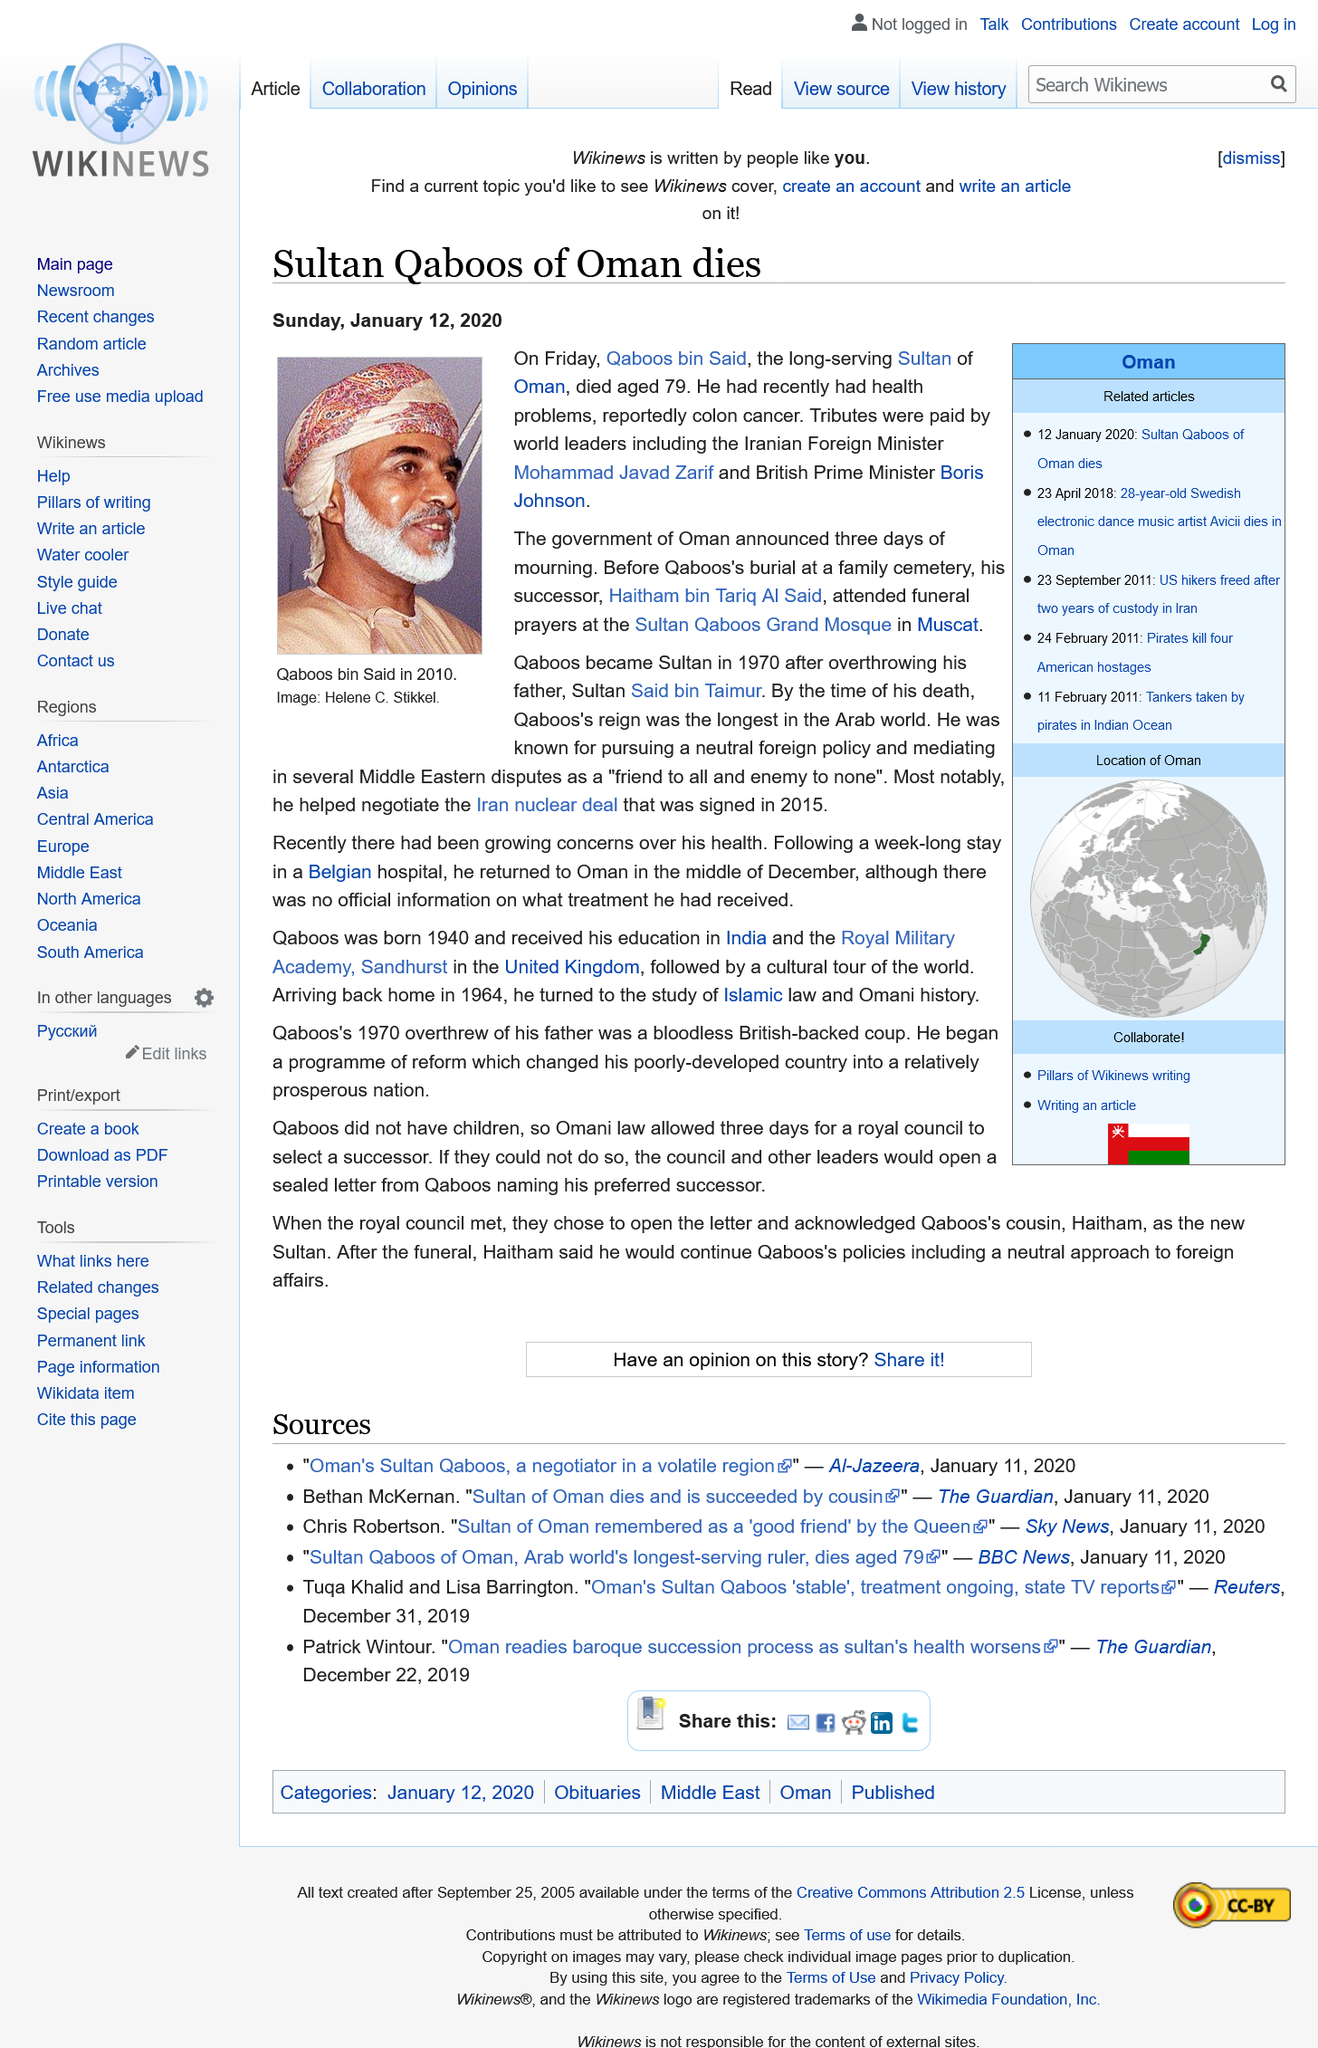Give some essential details in this illustration. Sultan Qaboos died at the age of 79 and was succeeded by his son, Haitham bin Tariq, who was crowned as the new sultan. The government of Oman announced three days of mourning following the passing of Sultan Qaboos. Qaboos overthrew his father, Sultan Said bin Taimur, in 1970 and subsequently became the Sultan of Oman. Sultan Qaboos, the longest serving leader in the Arab world, was known for pursuing a neutral foreign policy and mediating in the Arab world. 